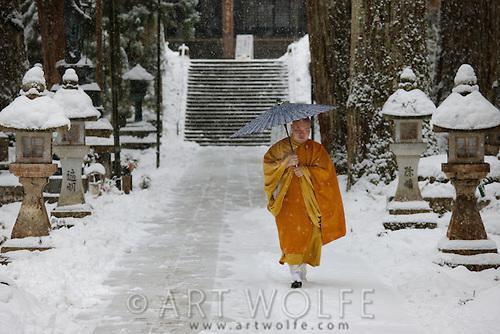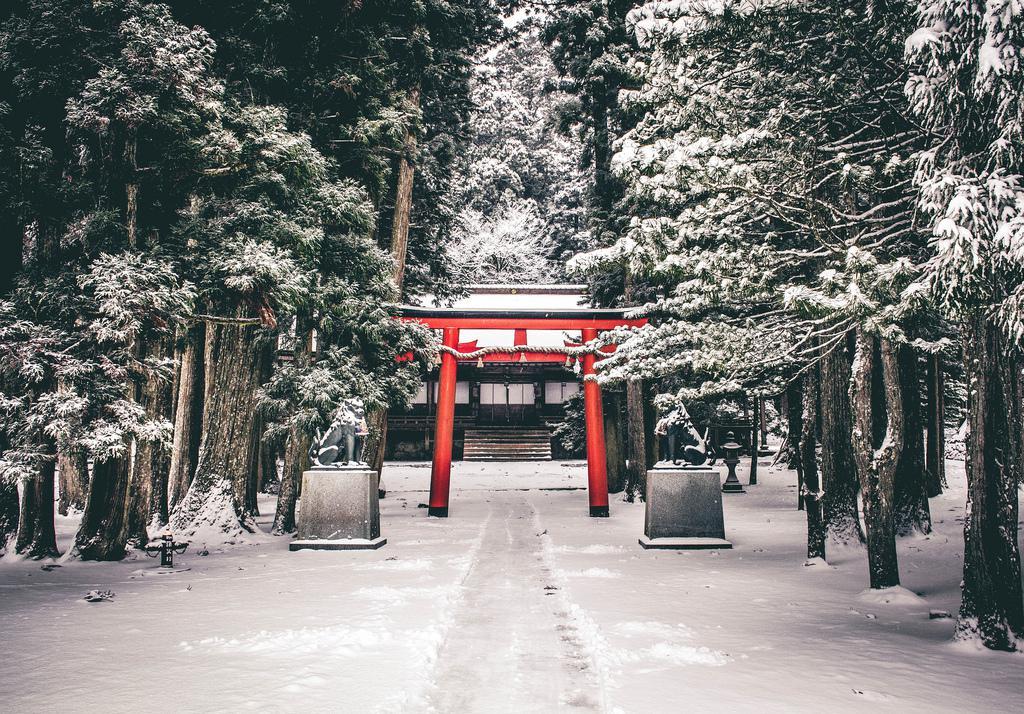The first image is the image on the left, the second image is the image on the right. Analyze the images presented: Is the assertion "The red posts of a Buddhist shrine can be seen in one image, while a single monk walks on a stone path in the other image." valid? Answer yes or no. Yes. The first image is the image on the left, the second image is the image on the right. Evaluate the accuracy of this statement regarding the images: "An image shows at least three people in golden-yellow robes walking in a snowy scene.". Is it true? Answer yes or no. No. 